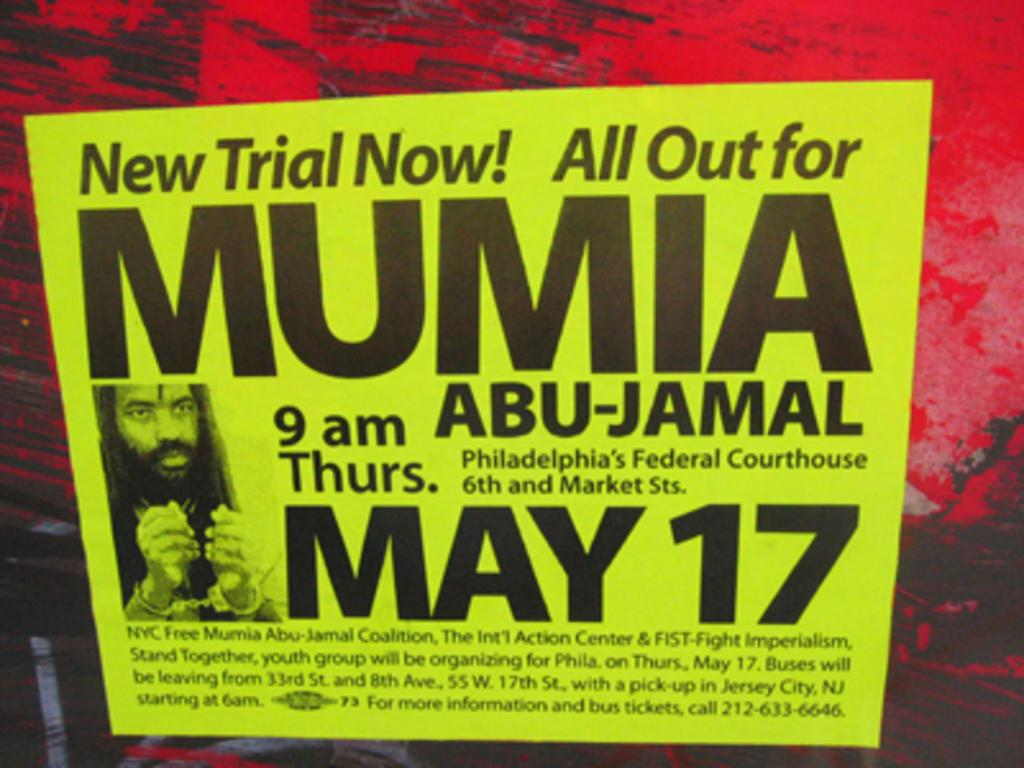Provide a one-sentence caption for the provided image. a flyer for the date of may 17  for mumia. 